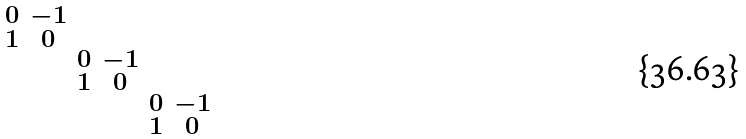<formula> <loc_0><loc_0><loc_500><loc_500>\begin{smallmatrix} 0 & - 1 & & & & \\ 1 & 0 & & & & \\ & & 0 & - 1 & & \\ & & 1 & 0 & & \\ & & & & 0 & - 1 \\ & & & & 1 & 0 \end{smallmatrix}</formula> 